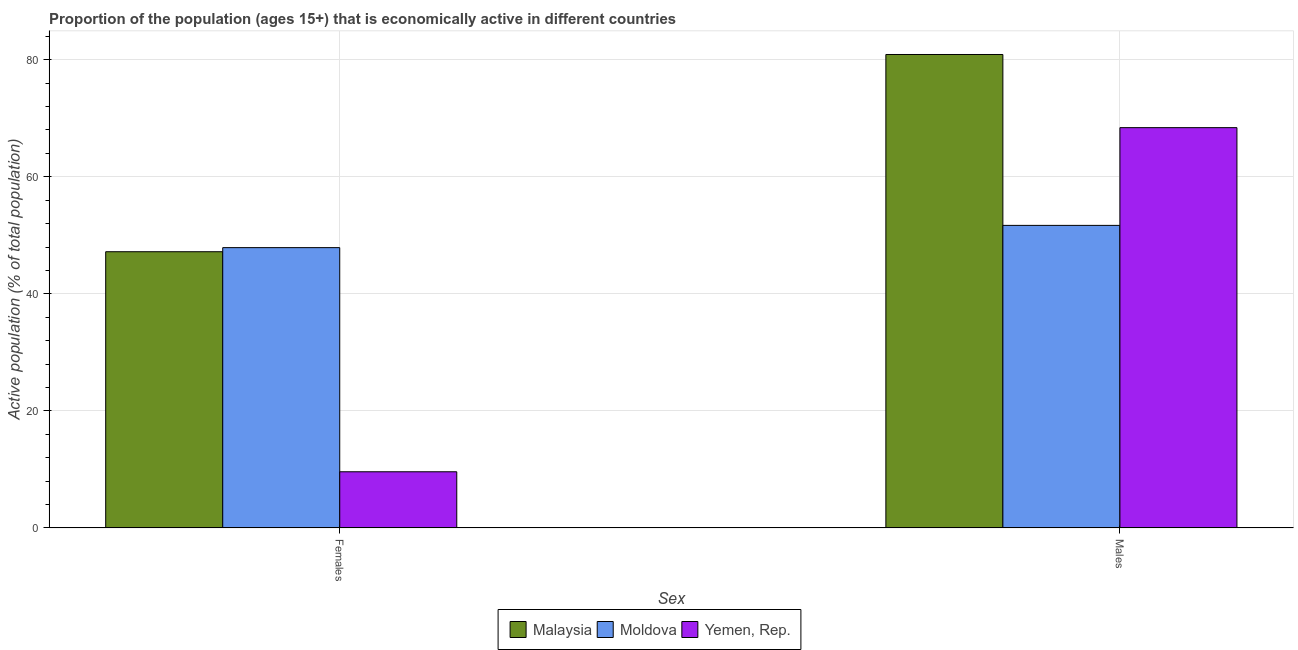How many groups of bars are there?
Your answer should be compact. 2. Are the number of bars per tick equal to the number of legend labels?
Ensure brevity in your answer.  Yes. Are the number of bars on each tick of the X-axis equal?
Your response must be concise. Yes. What is the label of the 1st group of bars from the left?
Give a very brief answer. Females. What is the percentage of economically active female population in Yemen, Rep.?
Your response must be concise. 9.6. Across all countries, what is the maximum percentage of economically active female population?
Offer a terse response. 47.9. Across all countries, what is the minimum percentage of economically active male population?
Offer a very short reply. 51.7. In which country was the percentage of economically active male population maximum?
Offer a very short reply. Malaysia. In which country was the percentage of economically active female population minimum?
Ensure brevity in your answer.  Yemen, Rep. What is the total percentage of economically active female population in the graph?
Offer a very short reply. 104.7. What is the difference between the percentage of economically active female population in Malaysia and that in Yemen, Rep.?
Provide a succinct answer. 37.6. What is the difference between the percentage of economically active male population in Malaysia and the percentage of economically active female population in Moldova?
Keep it short and to the point. 33. What is the average percentage of economically active male population per country?
Offer a very short reply. 67. What is the difference between the percentage of economically active male population and percentage of economically active female population in Malaysia?
Give a very brief answer. 33.7. In how many countries, is the percentage of economically active female population greater than 40 %?
Provide a succinct answer. 2. What is the ratio of the percentage of economically active female population in Moldova to that in Yemen, Rep.?
Your answer should be very brief. 4.99. Is the percentage of economically active female population in Moldova less than that in Yemen, Rep.?
Provide a succinct answer. No. In how many countries, is the percentage of economically active female population greater than the average percentage of economically active female population taken over all countries?
Give a very brief answer. 2. What does the 1st bar from the left in Females represents?
Your answer should be very brief. Malaysia. What does the 2nd bar from the right in Females represents?
Provide a short and direct response. Moldova. Are the values on the major ticks of Y-axis written in scientific E-notation?
Give a very brief answer. No. Does the graph contain any zero values?
Offer a terse response. No. Where does the legend appear in the graph?
Your answer should be very brief. Bottom center. How many legend labels are there?
Offer a terse response. 3. What is the title of the graph?
Give a very brief answer. Proportion of the population (ages 15+) that is economically active in different countries. What is the label or title of the X-axis?
Offer a terse response. Sex. What is the label or title of the Y-axis?
Your response must be concise. Active population (% of total population). What is the Active population (% of total population) of Malaysia in Females?
Your answer should be compact. 47.2. What is the Active population (% of total population) of Moldova in Females?
Your response must be concise. 47.9. What is the Active population (% of total population) in Yemen, Rep. in Females?
Keep it short and to the point. 9.6. What is the Active population (% of total population) of Malaysia in Males?
Your answer should be very brief. 80.9. What is the Active population (% of total population) in Moldova in Males?
Ensure brevity in your answer.  51.7. What is the Active population (% of total population) in Yemen, Rep. in Males?
Make the answer very short. 68.4. Across all Sex, what is the maximum Active population (% of total population) of Malaysia?
Give a very brief answer. 80.9. Across all Sex, what is the maximum Active population (% of total population) of Moldova?
Ensure brevity in your answer.  51.7. Across all Sex, what is the maximum Active population (% of total population) of Yemen, Rep.?
Keep it short and to the point. 68.4. Across all Sex, what is the minimum Active population (% of total population) in Malaysia?
Ensure brevity in your answer.  47.2. Across all Sex, what is the minimum Active population (% of total population) in Moldova?
Offer a terse response. 47.9. Across all Sex, what is the minimum Active population (% of total population) in Yemen, Rep.?
Keep it short and to the point. 9.6. What is the total Active population (% of total population) of Malaysia in the graph?
Ensure brevity in your answer.  128.1. What is the total Active population (% of total population) of Moldova in the graph?
Your answer should be very brief. 99.6. What is the difference between the Active population (% of total population) of Malaysia in Females and that in Males?
Your response must be concise. -33.7. What is the difference between the Active population (% of total population) of Yemen, Rep. in Females and that in Males?
Your response must be concise. -58.8. What is the difference between the Active population (% of total population) in Malaysia in Females and the Active population (% of total population) in Yemen, Rep. in Males?
Provide a short and direct response. -21.2. What is the difference between the Active population (% of total population) in Moldova in Females and the Active population (% of total population) in Yemen, Rep. in Males?
Provide a succinct answer. -20.5. What is the average Active population (% of total population) of Malaysia per Sex?
Your response must be concise. 64.05. What is the average Active population (% of total population) in Moldova per Sex?
Your answer should be compact. 49.8. What is the difference between the Active population (% of total population) of Malaysia and Active population (% of total population) of Moldova in Females?
Your answer should be compact. -0.7. What is the difference between the Active population (% of total population) of Malaysia and Active population (% of total population) of Yemen, Rep. in Females?
Keep it short and to the point. 37.6. What is the difference between the Active population (% of total population) in Moldova and Active population (% of total population) in Yemen, Rep. in Females?
Your answer should be very brief. 38.3. What is the difference between the Active population (% of total population) in Malaysia and Active population (% of total population) in Moldova in Males?
Ensure brevity in your answer.  29.2. What is the difference between the Active population (% of total population) of Moldova and Active population (% of total population) of Yemen, Rep. in Males?
Your response must be concise. -16.7. What is the ratio of the Active population (% of total population) of Malaysia in Females to that in Males?
Ensure brevity in your answer.  0.58. What is the ratio of the Active population (% of total population) of Moldova in Females to that in Males?
Make the answer very short. 0.93. What is the ratio of the Active population (% of total population) in Yemen, Rep. in Females to that in Males?
Offer a very short reply. 0.14. What is the difference between the highest and the second highest Active population (% of total population) in Malaysia?
Your response must be concise. 33.7. What is the difference between the highest and the second highest Active population (% of total population) in Yemen, Rep.?
Make the answer very short. 58.8. What is the difference between the highest and the lowest Active population (% of total population) of Malaysia?
Offer a terse response. 33.7. What is the difference between the highest and the lowest Active population (% of total population) of Moldova?
Give a very brief answer. 3.8. What is the difference between the highest and the lowest Active population (% of total population) of Yemen, Rep.?
Ensure brevity in your answer.  58.8. 